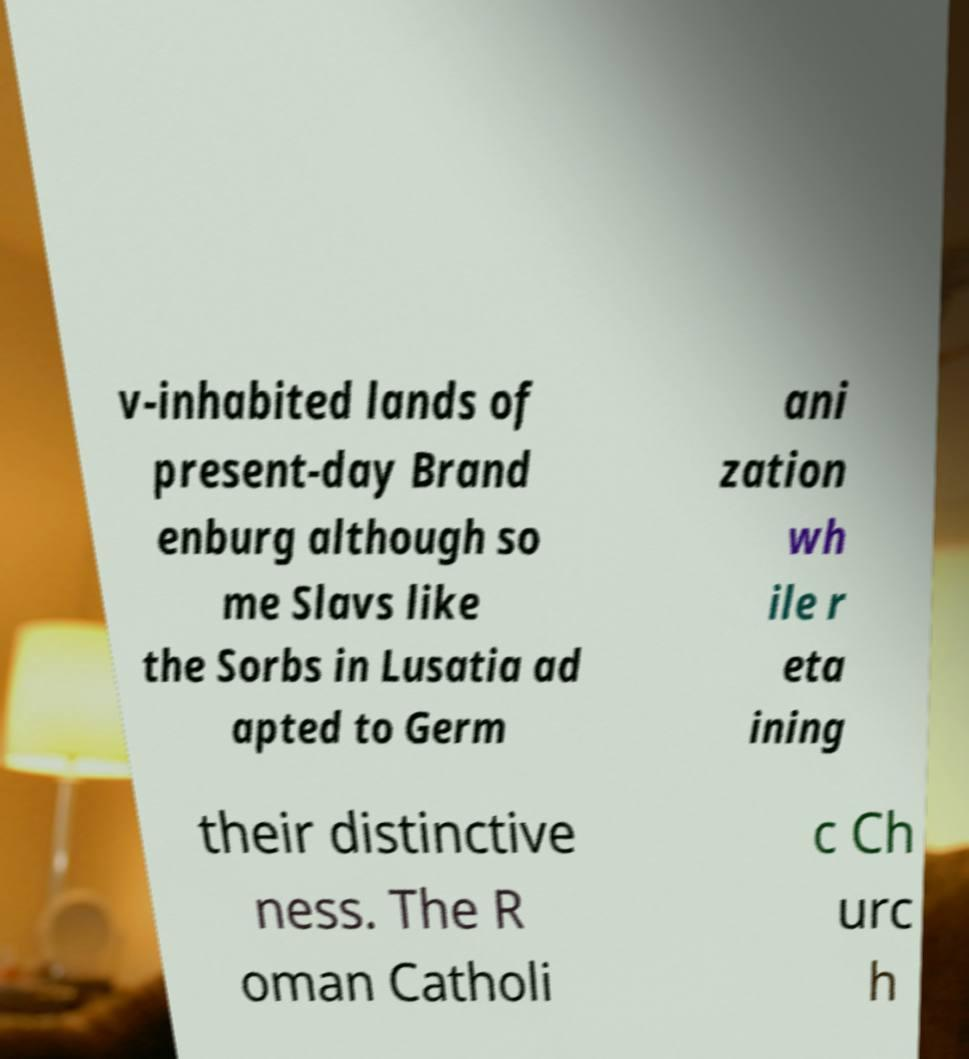Can you read and provide the text displayed in the image?This photo seems to have some interesting text. Can you extract and type it out for me? v-inhabited lands of present-day Brand enburg although so me Slavs like the Sorbs in Lusatia ad apted to Germ ani zation wh ile r eta ining their distinctive ness. The R oman Catholi c Ch urc h 